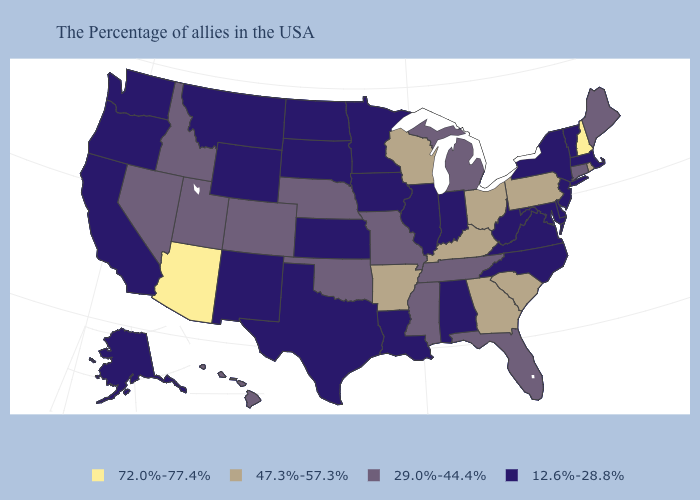What is the highest value in the West ?
Quick response, please. 72.0%-77.4%. What is the value of Nebraska?
Write a very short answer. 29.0%-44.4%. What is the value of Louisiana?
Concise answer only. 12.6%-28.8%. Which states hav the highest value in the Northeast?
Write a very short answer. New Hampshire. What is the value of North Dakota?
Be succinct. 12.6%-28.8%. What is the value of North Dakota?
Keep it brief. 12.6%-28.8%. Among the states that border Arizona , does California have the lowest value?
Answer briefly. Yes. Among the states that border Virginia , which have the lowest value?
Answer briefly. Maryland, North Carolina, West Virginia. What is the lowest value in the Northeast?
Write a very short answer. 12.6%-28.8%. What is the value of Maine?
Short answer required. 29.0%-44.4%. Does Idaho have a higher value than Missouri?
Give a very brief answer. No. Among the states that border Texas , does Arkansas have the highest value?
Write a very short answer. Yes. What is the value of Hawaii?
Be succinct. 29.0%-44.4%. What is the highest value in the South ?
Short answer required. 47.3%-57.3%. Which states have the lowest value in the MidWest?
Concise answer only. Indiana, Illinois, Minnesota, Iowa, Kansas, South Dakota, North Dakota. 